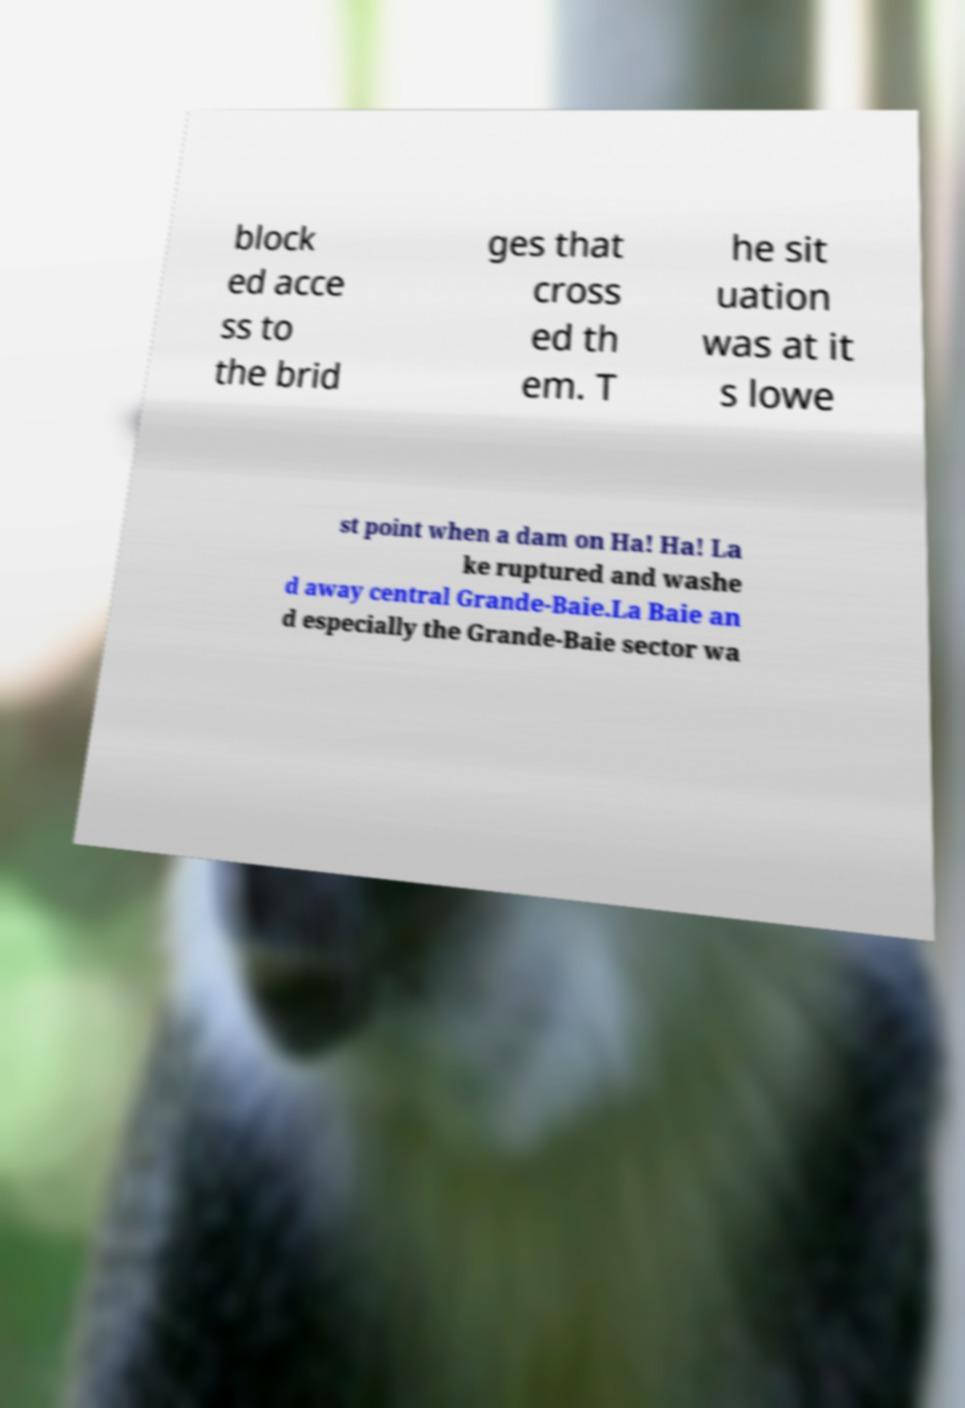What messages or text are displayed in this image? I need them in a readable, typed format. block ed acce ss to the brid ges that cross ed th em. T he sit uation was at it s lowe st point when a dam on Ha! Ha! La ke ruptured and washe d away central Grande-Baie.La Baie an d especially the Grande-Baie sector wa 